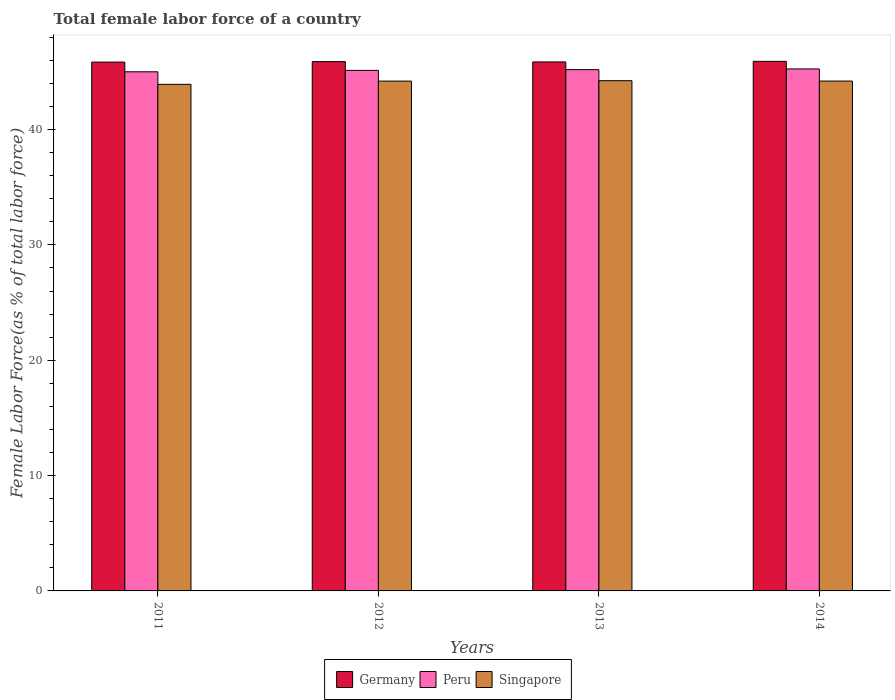Are the number of bars per tick equal to the number of legend labels?
Keep it short and to the point. Yes. Are the number of bars on each tick of the X-axis equal?
Your answer should be compact. Yes. How many bars are there on the 1st tick from the right?
Offer a very short reply. 3. What is the percentage of female labor force in Peru in 2013?
Give a very brief answer. 45.19. Across all years, what is the maximum percentage of female labor force in Singapore?
Your answer should be very brief. 44.24. Across all years, what is the minimum percentage of female labor force in Germany?
Offer a very short reply. 45.85. In which year was the percentage of female labor force in Singapore minimum?
Ensure brevity in your answer.  2011. What is the total percentage of female labor force in Germany in the graph?
Your answer should be very brief. 183.52. What is the difference between the percentage of female labor force in Singapore in 2012 and that in 2014?
Give a very brief answer. -0. What is the difference between the percentage of female labor force in Germany in 2011 and the percentage of female labor force in Peru in 2012?
Provide a succinct answer. 0.72. What is the average percentage of female labor force in Peru per year?
Offer a very short reply. 45.15. In the year 2011, what is the difference between the percentage of female labor force in Germany and percentage of female labor force in Peru?
Offer a very short reply. 0.84. What is the ratio of the percentage of female labor force in Peru in 2011 to that in 2014?
Give a very brief answer. 0.99. What is the difference between the highest and the second highest percentage of female labor force in Peru?
Your answer should be compact. 0.06. What is the difference between the highest and the lowest percentage of female labor force in Peru?
Provide a succinct answer. 0.25. In how many years, is the percentage of female labor force in Singapore greater than the average percentage of female labor force in Singapore taken over all years?
Offer a terse response. 3. Is the sum of the percentage of female labor force in Germany in 2011 and 2013 greater than the maximum percentage of female labor force in Singapore across all years?
Offer a terse response. Yes. What does the 1st bar from the left in 2013 represents?
Make the answer very short. Germany. What does the 1st bar from the right in 2011 represents?
Make the answer very short. Singapore. How many bars are there?
Provide a short and direct response. 12. How are the legend labels stacked?
Your answer should be very brief. Horizontal. What is the title of the graph?
Provide a succinct answer. Total female labor force of a country. Does "St. Vincent and the Grenadines" appear as one of the legend labels in the graph?
Ensure brevity in your answer.  No. What is the label or title of the Y-axis?
Give a very brief answer. Female Labor Force(as % of total labor force). What is the Female Labor Force(as % of total labor force) in Germany in 2011?
Offer a terse response. 45.85. What is the Female Labor Force(as % of total labor force) of Peru in 2011?
Keep it short and to the point. 45.01. What is the Female Labor Force(as % of total labor force) in Singapore in 2011?
Provide a succinct answer. 43.92. What is the Female Labor Force(as % of total labor force) of Germany in 2012?
Your answer should be compact. 45.89. What is the Female Labor Force(as % of total labor force) of Peru in 2012?
Give a very brief answer. 45.13. What is the Female Labor Force(as % of total labor force) in Singapore in 2012?
Ensure brevity in your answer.  44.2. What is the Female Labor Force(as % of total labor force) of Germany in 2013?
Your response must be concise. 45.86. What is the Female Labor Force(as % of total labor force) of Peru in 2013?
Give a very brief answer. 45.19. What is the Female Labor Force(as % of total labor force) of Singapore in 2013?
Make the answer very short. 44.24. What is the Female Labor Force(as % of total labor force) in Germany in 2014?
Ensure brevity in your answer.  45.91. What is the Female Labor Force(as % of total labor force) of Peru in 2014?
Give a very brief answer. 45.26. What is the Female Labor Force(as % of total labor force) of Singapore in 2014?
Provide a short and direct response. 44.21. Across all years, what is the maximum Female Labor Force(as % of total labor force) of Germany?
Your answer should be very brief. 45.91. Across all years, what is the maximum Female Labor Force(as % of total labor force) of Peru?
Give a very brief answer. 45.26. Across all years, what is the maximum Female Labor Force(as % of total labor force) of Singapore?
Provide a succinct answer. 44.24. Across all years, what is the minimum Female Labor Force(as % of total labor force) of Germany?
Ensure brevity in your answer.  45.85. Across all years, what is the minimum Female Labor Force(as % of total labor force) in Peru?
Offer a very short reply. 45.01. Across all years, what is the minimum Female Labor Force(as % of total labor force) of Singapore?
Your response must be concise. 43.92. What is the total Female Labor Force(as % of total labor force) in Germany in the graph?
Keep it short and to the point. 183.52. What is the total Female Labor Force(as % of total labor force) in Peru in the graph?
Offer a terse response. 180.59. What is the total Female Labor Force(as % of total labor force) in Singapore in the graph?
Provide a short and direct response. 176.57. What is the difference between the Female Labor Force(as % of total labor force) of Germany in 2011 and that in 2012?
Provide a short and direct response. -0.04. What is the difference between the Female Labor Force(as % of total labor force) of Peru in 2011 and that in 2012?
Provide a short and direct response. -0.12. What is the difference between the Female Labor Force(as % of total labor force) in Singapore in 2011 and that in 2012?
Make the answer very short. -0.28. What is the difference between the Female Labor Force(as % of total labor force) in Germany in 2011 and that in 2013?
Keep it short and to the point. -0.01. What is the difference between the Female Labor Force(as % of total labor force) of Peru in 2011 and that in 2013?
Ensure brevity in your answer.  -0.19. What is the difference between the Female Labor Force(as % of total labor force) in Singapore in 2011 and that in 2013?
Keep it short and to the point. -0.32. What is the difference between the Female Labor Force(as % of total labor force) of Germany in 2011 and that in 2014?
Provide a succinct answer. -0.07. What is the difference between the Female Labor Force(as % of total labor force) of Peru in 2011 and that in 2014?
Ensure brevity in your answer.  -0.25. What is the difference between the Female Labor Force(as % of total labor force) in Singapore in 2011 and that in 2014?
Your response must be concise. -0.29. What is the difference between the Female Labor Force(as % of total labor force) of Germany in 2012 and that in 2013?
Your answer should be compact. 0.03. What is the difference between the Female Labor Force(as % of total labor force) in Peru in 2012 and that in 2013?
Ensure brevity in your answer.  -0.06. What is the difference between the Female Labor Force(as % of total labor force) in Singapore in 2012 and that in 2013?
Offer a very short reply. -0.03. What is the difference between the Female Labor Force(as % of total labor force) in Germany in 2012 and that in 2014?
Ensure brevity in your answer.  -0.02. What is the difference between the Female Labor Force(as % of total labor force) in Peru in 2012 and that in 2014?
Offer a very short reply. -0.13. What is the difference between the Female Labor Force(as % of total labor force) of Singapore in 2012 and that in 2014?
Your answer should be compact. -0. What is the difference between the Female Labor Force(as % of total labor force) in Germany in 2013 and that in 2014?
Your response must be concise. -0.05. What is the difference between the Female Labor Force(as % of total labor force) of Peru in 2013 and that in 2014?
Your answer should be compact. -0.06. What is the difference between the Female Labor Force(as % of total labor force) in Singapore in 2013 and that in 2014?
Give a very brief answer. 0.03. What is the difference between the Female Labor Force(as % of total labor force) in Germany in 2011 and the Female Labor Force(as % of total labor force) in Peru in 2012?
Give a very brief answer. 0.72. What is the difference between the Female Labor Force(as % of total labor force) of Germany in 2011 and the Female Labor Force(as % of total labor force) of Singapore in 2012?
Your answer should be compact. 1.65. What is the difference between the Female Labor Force(as % of total labor force) of Peru in 2011 and the Female Labor Force(as % of total labor force) of Singapore in 2012?
Offer a terse response. 0.81. What is the difference between the Female Labor Force(as % of total labor force) of Germany in 2011 and the Female Labor Force(as % of total labor force) of Peru in 2013?
Offer a terse response. 0.65. What is the difference between the Female Labor Force(as % of total labor force) in Germany in 2011 and the Female Labor Force(as % of total labor force) in Singapore in 2013?
Ensure brevity in your answer.  1.61. What is the difference between the Female Labor Force(as % of total labor force) of Peru in 2011 and the Female Labor Force(as % of total labor force) of Singapore in 2013?
Your answer should be compact. 0.77. What is the difference between the Female Labor Force(as % of total labor force) in Germany in 2011 and the Female Labor Force(as % of total labor force) in Peru in 2014?
Your response must be concise. 0.59. What is the difference between the Female Labor Force(as % of total labor force) of Germany in 2011 and the Female Labor Force(as % of total labor force) of Singapore in 2014?
Provide a short and direct response. 1.64. What is the difference between the Female Labor Force(as % of total labor force) in Peru in 2011 and the Female Labor Force(as % of total labor force) in Singapore in 2014?
Provide a short and direct response. 0.8. What is the difference between the Female Labor Force(as % of total labor force) of Germany in 2012 and the Female Labor Force(as % of total labor force) of Peru in 2013?
Offer a terse response. 0.7. What is the difference between the Female Labor Force(as % of total labor force) in Germany in 2012 and the Female Labor Force(as % of total labor force) in Singapore in 2013?
Offer a very short reply. 1.65. What is the difference between the Female Labor Force(as % of total labor force) in Peru in 2012 and the Female Labor Force(as % of total labor force) in Singapore in 2013?
Your answer should be very brief. 0.9. What is the difference between the Female Labor Force(as % of total labor force) in Germany in 2012 and the Female Labor Force(as % of total labor force) in Peru in 2014?
Your answer should be compact. 0.63. What is the difference between the Female Labor Force(as % of total labor force) in Germany in 2012 and the Female Labor Force(as % of total labor force) in Singapore in 2014?
Provide a succinct answer. 1.69. What is the difference between the Female Labor Force(as % of total labor force) of Peru in 2012 and the Female Labor Force(as % of total labor force) of Singapore in 2014?
Give a very brief answer. 0.93. What is the difference between the Female Labor Force(as % of total labor force) in Germany in 2013 and the Female Labor Force(as % of total labor force) in Peru in 2014?
Provide a short and direct response. 0.61. What is the difference between the Female Labor Force(as % of total labor force) in Germany in 2013 and the Female Labor Force(as % of total labor force) in Singapore in 2014?
Keep it short and to the point. 1.66. What is the average Female Labor Force(as % of total labor force) in Germany per year?
Offer a terse response. 45.88. What is the average Female Labor Force(as % of total labor force) of Peru per year?
Give a very brief answer. 45.15. What is the average Female Labor Force(as % of total labor force) of Singapore per year?
Offer a very short reply. 44.14. In the year 2011, what is the difference between the Female Labor Force(as % of total labor force) of Germany and Female Labor Force(as % of total labor force) of Peru?
Give a very brief answer. 0.84. In the year 2011, what is the difference between the Female Labor Force(as % of total labor force) of Germany and Female Labor Force(as % of total labor force) of Singapore?
Give a very brief answer. 1.93. In the year 2011, what is the difference between the Female Labor Force(as % of total labor force) of Peru and Female Labor Force(as % of total labor force) of Singapore?
Give a very brief answer. 1.09. In the year 2012, what is the difference between the Female Labor Force(as % of total labor force) in Germany and Female Labor Force(as % of total labor force) in Peru?
Ensure brevity in your answer.  0.76. In the year 2012, what is the difference between the Female Labor Force(as % of total labor force) in Germany and Female Labor Force(as % of total labor force) in Singapore?
Offer a terse response. 1.69. In the year 2012, what is the difference between the Female Labor Force(as % of total labor force) in Peru and Female Labor Force(as % of total labor force) in Singapore?
Make the answer very short. 0.93. In the year 2013, what is the difference between the Female Labor Force(as % of total labor force) of Germany and Female Labor Force(as % of total labor force) of Peru?
Keep it short and to the point. 0.67. In the year 2013, what is the difference between the Female Labor Force(as % of total labor force) in Germany and Female Labor Force(as % of total labor force) in Singapore?
Give a very brief answer. 1.63. In the year 2013, what is the difference between the Female Labor Force(as % of total labor force) in Peru and Female Labor Force(as % of total labor force) in Singapore?
Ensure brevity in your answer.  0.96. In the year 2014, what is the difference between the Female Labor Force(as % of total labor force) in Germany and Female Labor Force(as % of total labor force) in Peru?
Make the answer very short. 0.66. In the year 2014, what is the difference between the Female Labor Force(as % of total labor force) of Germany and Female Labor Force(as % of total labor force) of Singapore?
Your answer should be very brief. 1.71. In the year 2014, what is the difference between the Female Labor Force(as % of total labor force) in Peru and Female Labor Force(as % of total labor force) in Singapore?
Your answer should be compact. 1.05. What is the ratio of the Female Labor Force(as % of total labor force) in Singapore in 2011 to that in 2014?
Your answer should be very brief. 0.99. What is the ratio of the Female Labor Force(as % of total labor force) in Germany in 2012 to that in 2013?
Your response must be concise. 1. What is the ratio of the Female Labor Force(as % of total labor force) in Singapore in 2012 to that in 2013?
Your answer should be very brief. 1. What is the ratio of the Female Labor Force(as % of total labor force) of Germany in 2012 to that in 2014?
Keep it short and to the point. 1. What is the ratio of the Female Labor Force(as % of total labor force) of Peru in 2012 to that in 2014?
Your response must be concise. 1. What is the ratio of the Female Labor Force(as % of total labor force) of Peru in 2013 to that in 2014?
Your answer should be very brief. 1. What is the ratio of the Female Labor Force(as % of total labor force) of Singapore in 2013 to that in 2014?
Make the answer very short. 1. What is the difference between the highest and the second highest Female Labor Force(as % of total labor force) in Germany?
Offer a terse response. 0.02. What is the difference between the highest and the second highest Female Labor Force(as % of total labor force) in Peru?
Provide a short and direct response. 0.06. What is the difference between the highest and the second highest Female Labor Force(as % of total labor force) of Singapore?
Offer a very short reply. 0.03. What is the difference between the highest and the lowest Female Labor Force(as % of total labor force) of Germany?
Give a very brief answer. 0.07. What is the difference between the highest and the lowest Female Labor Force(as % of total labor force) of Peru?
Offer a very short reply. 0.25. What is the difference between the highest and the lowest Female Labor Force(as % of total labor force) of Singapore?
Keep it short and to the point. 0.32. 